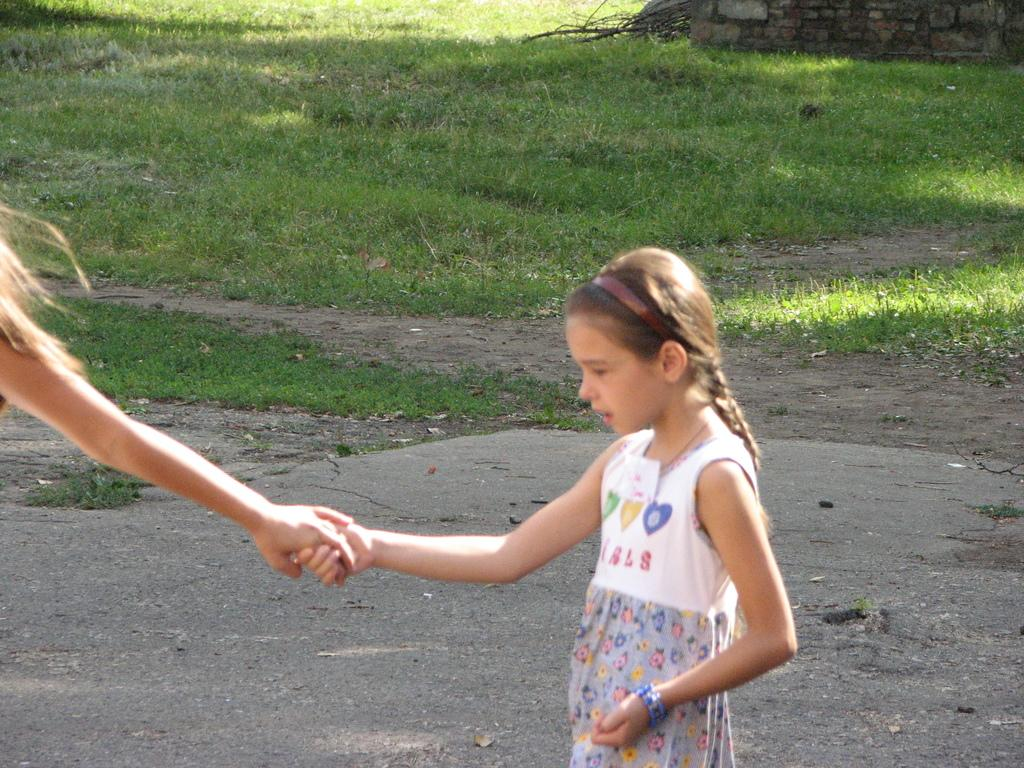Who is the main subject in the front of the image? There is a girl in the front of the image. What else can be seen in the front of the image? There is a person's hand in the front of the image. What is visible in the background of the image? There is a wall, branches, and grass in the background of the image. What month is it in the image? The month cannot be determined from the image, as there is no information about the time of year or season. 